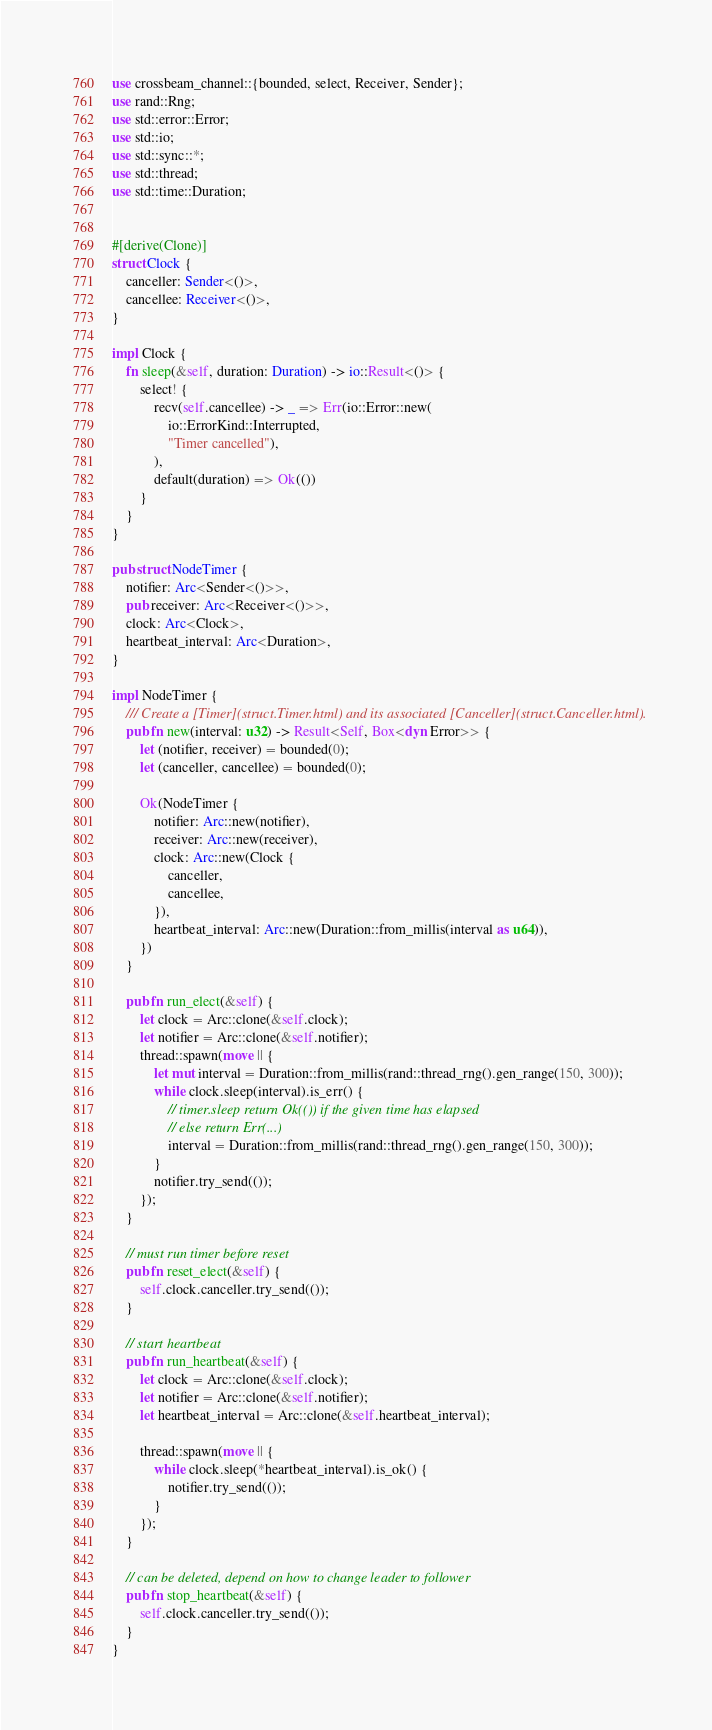<code> <loc_0><loc_0><loc_500><loc_500><_Rust_>use crossbeam_channel::{bounded, select, Receiver, Sender};
use rand::Rng;
use std::error::Error;
use std::io;
use std::sync::*;
use std::thread;
use std::time::Duration;


#[derive(Clone)]
struct Clock {
    canceller: Sender<()>,
    cancellee: Receiver<()>,
}

impl Clock {
    fn sleep(&self, duration: Duration) -> io::Result<()> {
        select! {
            recv(self.cancellee) -> _ => Err(io::Error::new(
                io::ErrorKind::Interrupted,
                "Timer cancelled"),
            ),
            default(duration) => Ok(())
        }
    }
}

pub struct NodeTimer {
    notifier: Arc<Sender<()>>,
    pub receiver: Arc<Receiver<()>>,
    clock: Arc<Clock>,
    heartbeat_interval: Arc<Duration>,
}

impl NodeTimer {
    /// Create a [Timer](struct.Timer.html) and its associated [Canceller](struct.Canceller.html).
    pub fn new(interval: u32) -> Result<Self, Box<dyn Error>> {
        let (notifier, receiver) = bounded(0);
        let (canceller, cancellee) = bounded(0);

        Ok(NodeTimer {
            notifier: Arc::new(notifier),
            receiver: Arc::new(receiver),
            clock: Arc::new(Clock {
                canceller,
                cancellee,
            }),
            heartbeat_interval: Arc::new(Duration::from_millis(interval as u64)),
        })
    }

    pub fn run_elect(&self) {
        let clock = Arc::clone(&self.clock);
        let notifier = Arc::clone(&self.notifier);
        thread::spawn(move || {
            let mut interval = Duration::from_millis(rand::thread_rng().gen_range(150, 300));
            while clock.sleep(interval).is_err() {
                // timer.sleep return Ok(()) if the given time has elapsed
                // else return Err(...)
                interval = Duration::from_millis(rand::thread_rng().gen_range(150, 300));
            }
            notifier.try_send(());
        });
    }

    // must run timer before reset
    pub fn reset_elect(&self) {
        self.clock.canceller.try_send(());
    }

    // start heartbeat
    pub fn run_heartbeat(&self) {
        let clock = Arc::clone(&self.clock);
        let notifier = Arc::clone(&self.notifier);
        let heartbeat_interval = Arc::clone(&self.heartbeat_interval);

        thread::spawn(move || {
            while clock.sleep(*heartbeat_interval).is_ok() {
                notifier.try_send(());
            }
        });
    }

    // can be deleted, depend on how to change leader to follower
    pub fn stop_heartbeat(&self) {
        self.clock.canceller.try_send(());
    }
}
</code> 